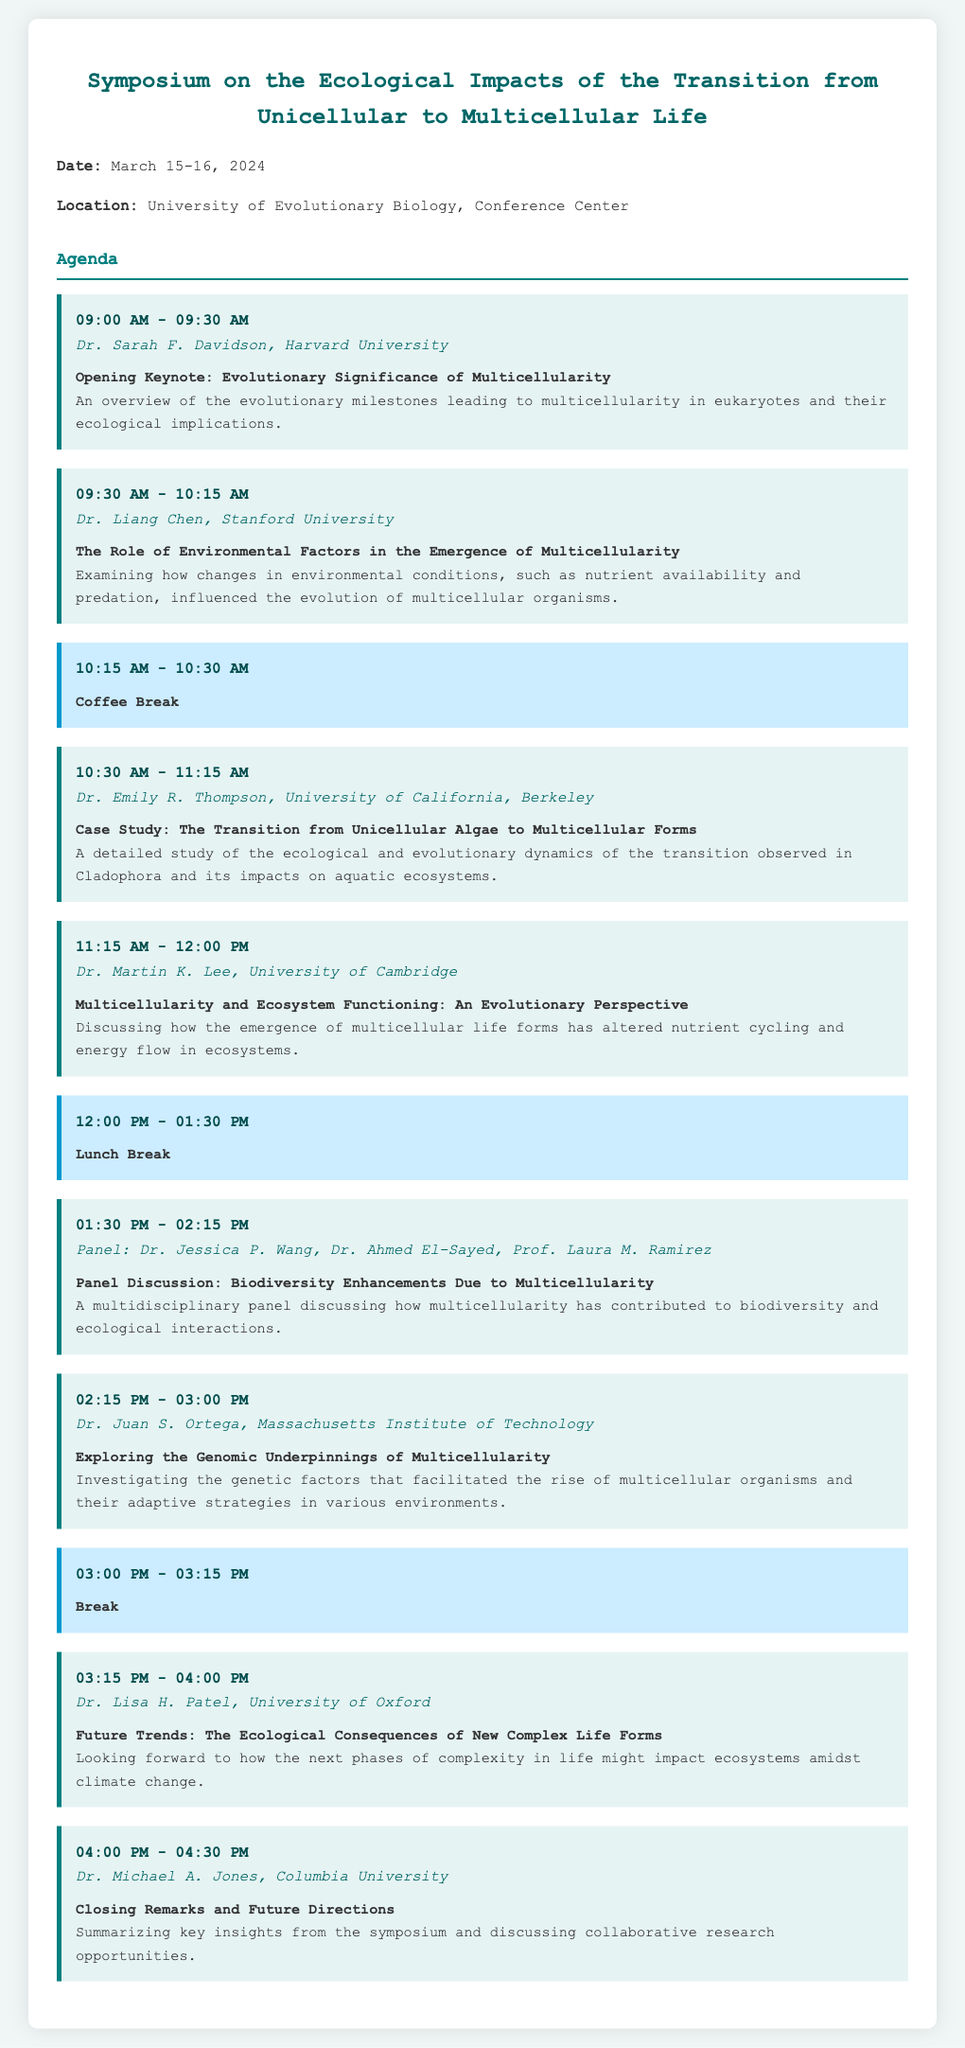What is the date of the symposium? The date is specified at the beginning of the document as March 15-16, 2024.
Answer: March 15-16, 2024 Who is the speaker for the opening keynote? The speaker is listed under the opening session as Dr. Sarah F. Davidson.
Answer: Dr. Sarah F. Davidson What is the title of the session led by Dr. Liang Chen? This session title can be found immediately under Dr. Liang Chen's name, describing his research topic.
Answer: The Role of Environmental Factors in the Emergence of Multicellularity What time does the lunch break start? The lunch break timing is provided under the session marking its start and end time as shown in the document.
Answer: 12:00 PM How many panelists are involved in the panel discussion? The number of panelists is listed in the session description for the panel discussion.
Answer: Three What institution does Dr. Juan S. Ortega represent? This information is found right below his name in his session designation.
Answer: Massachusetts Institute of Technology Who delivers the closing remarks at the symposium? The document specifies the speaker right before the closing remarks session.
Answer: Dr. Michael A. Jones What ecological topic is addressed in the session led by Dr. Lisa H. Patel? The session description provides insight into the ecological topics being addressed.
Answer: The Ecological Consequences of New Complex Life Forms 